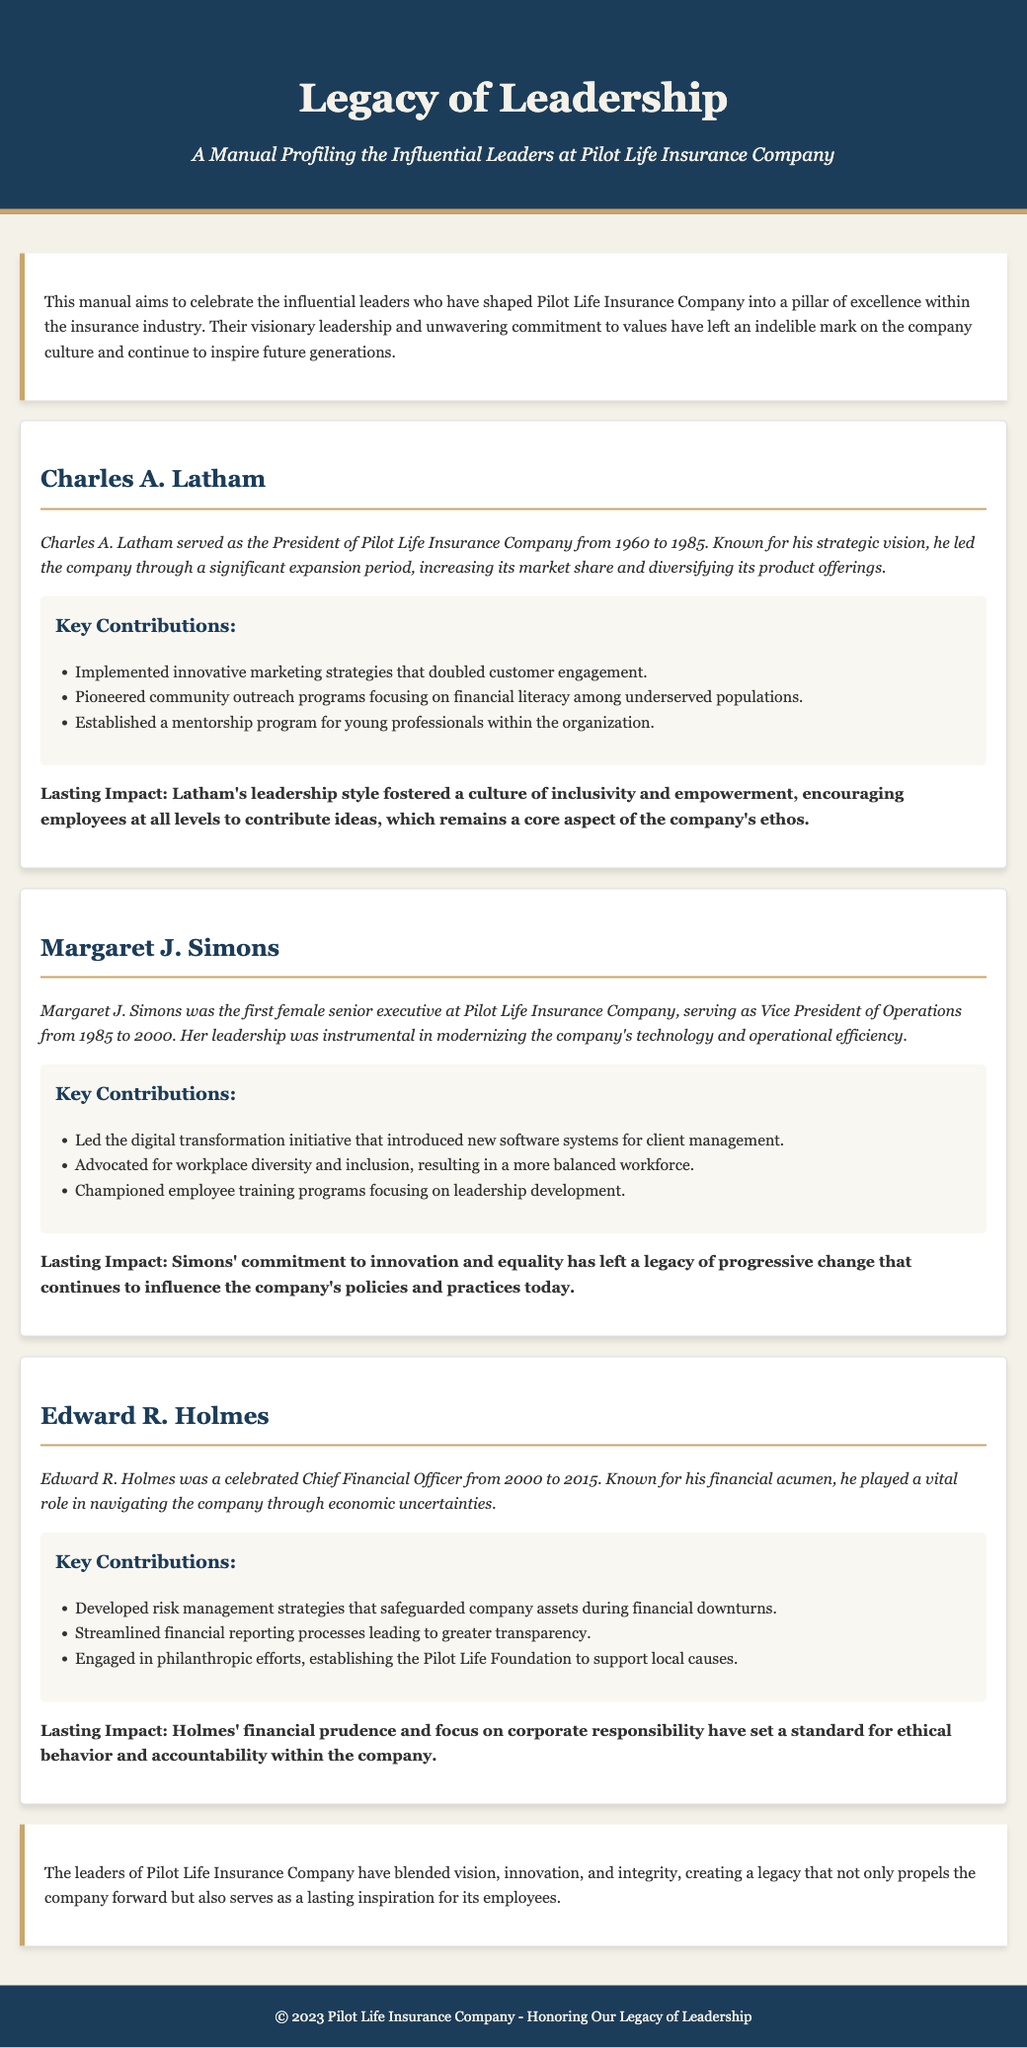What years did Charles A. Latham serve as President? The document states that Charles A. Latham served as President from 1960 to 1985.
Answer: 1960 to 1985 Who was the first female senior executive at Pilot Life Insurance Company? The manual identifies Margaret J. Simons as the first female senior executive at the company.
Answer: Margaret J. Simons What role did Edward R. Holmes hold at Pilot Life Insurance Company? According to the document, Edward R. Holmes was the Chief Financial Officer.
Answer: Chief Financial Officer What was a key contribution of Margaret J. Simons? The document mentions that one of her key contributions was leading the digital transformation initiative.
Answer: Digital transformation initiative What impact did Charles A. Latham have on company culture? The lasting impact of Latham's leadership style is noted as fostering a culture of inclusivity and empowerment.
Answer: Inclusivity and empowerment What year did Edward R. Holmes's tenure as CFO end? The manual indicates that Edward R. Holmes served until 2015.
Answer: 2015 What significant program did Charles A. Latham establish? The document states that he established a mentorship program for young professionals within the organization.
Answer: Mentorship program How long was Margaret J. Simons Vice President of Operations? The document specifies that she served from 1985 to 2000, which is a span of 15 years.
Answer: 15 years What foundation did Edward R. Holmes establish? According to the manual, he established the Pilot Life Foundation to support local causes.
Answer: Pilot Life Foundation 